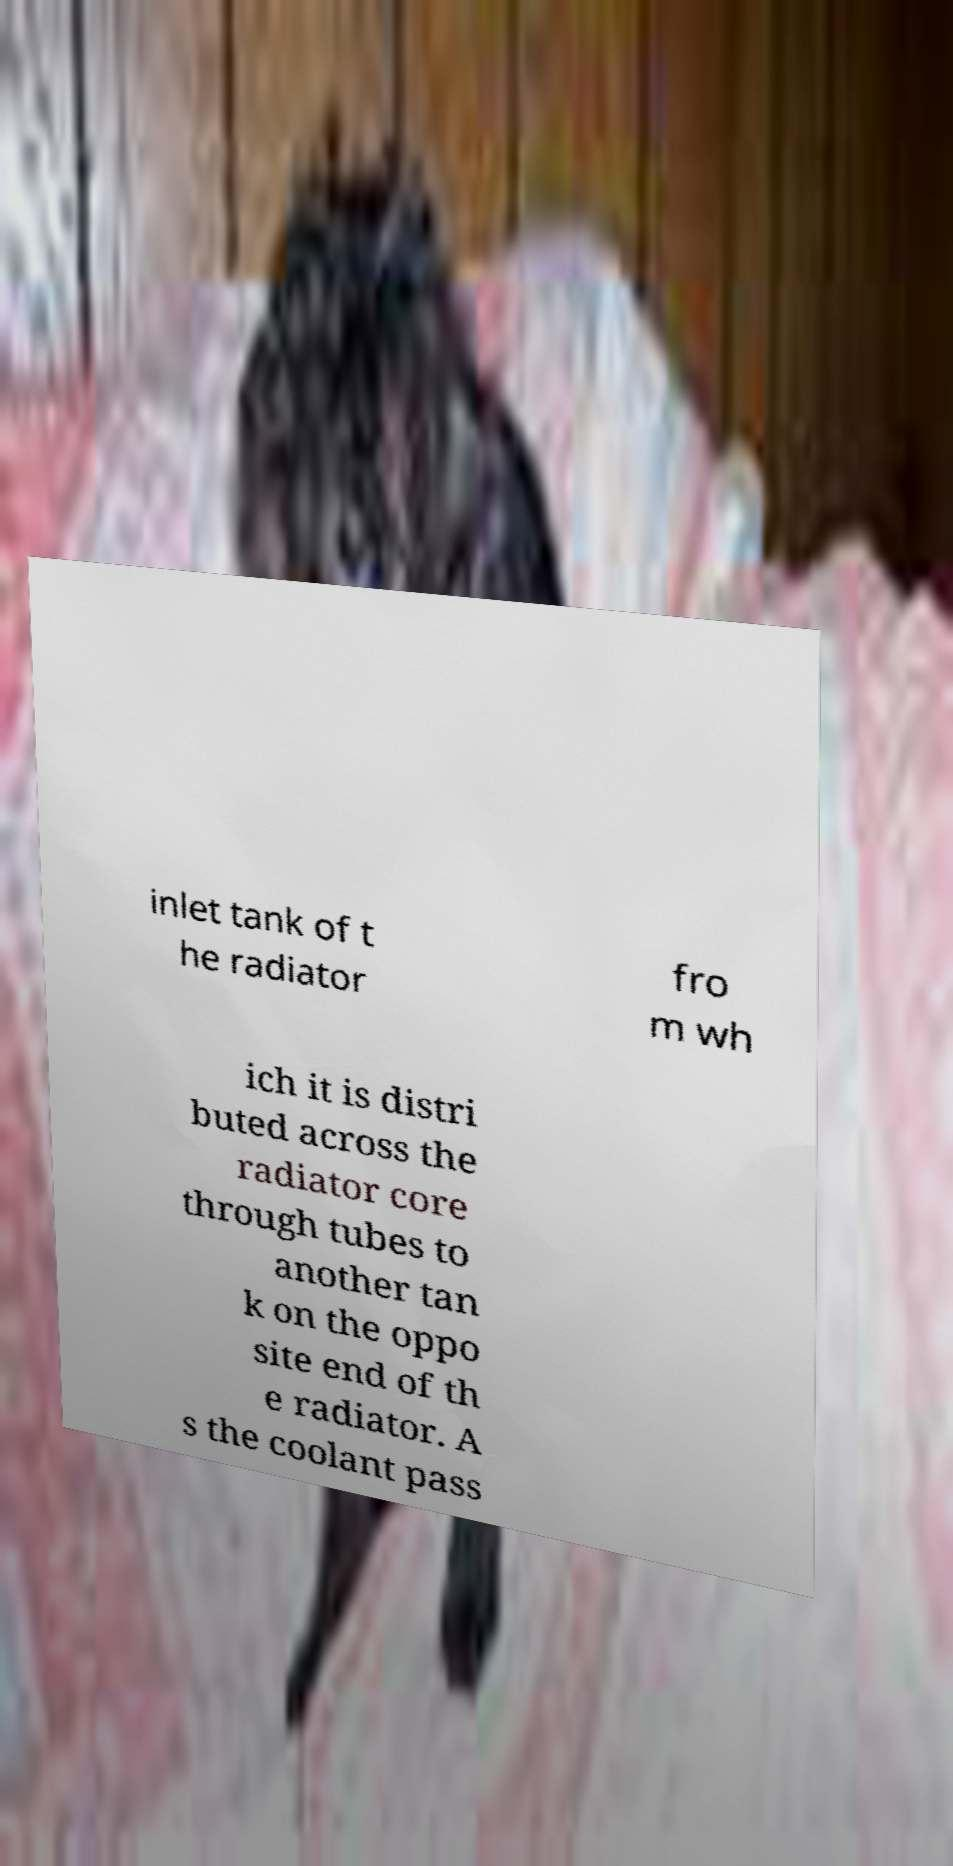What messages or text are displayed in this image? I need them in a readable, typed format. inlet tank of t he radiator fro m wh ich it is distri buted across the radiator core through tubes to another tan k on the oppo site end of th e radiator. A s the coolant pass 